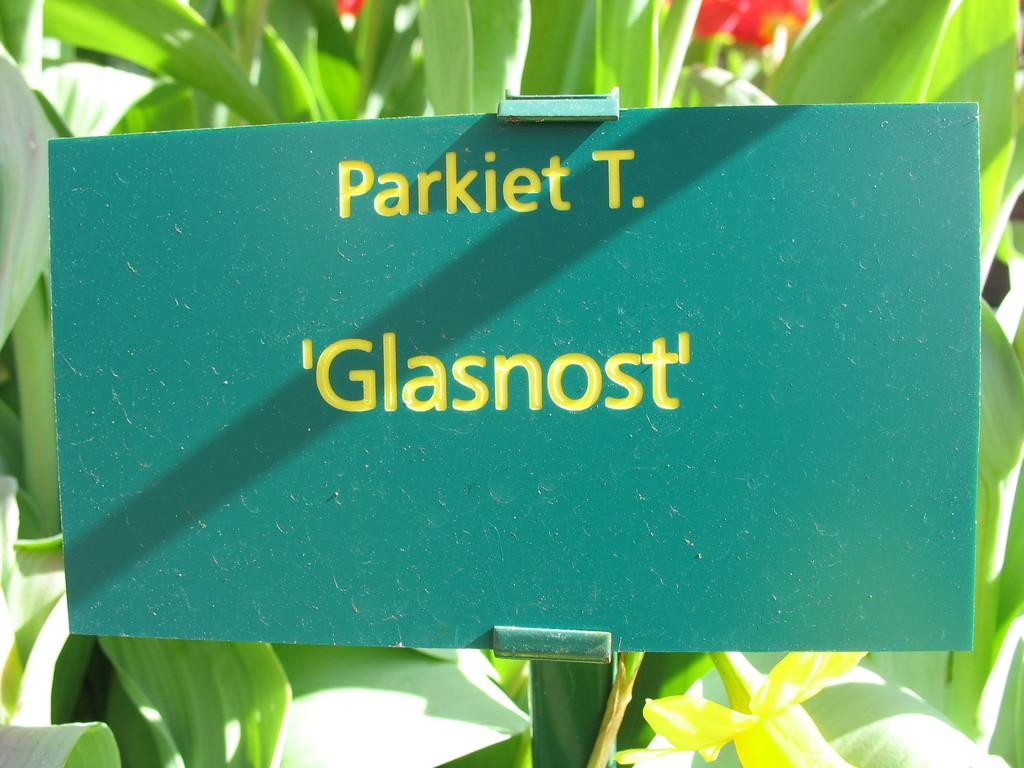What type of vegetation can be seen in the background of the image? There are plants in the background of the image. Can you identify any specific flowers among the plants? Yes, there appears to be a red flower among the plants. What is the primary color of the board in the image? The image is mainly highlighted with a green board. Is there any text or drawing on the green board? Yes, there is something written on the green board. What type of metal is used to create the bait for the fish in the image? There is no mention of fish or bait in the image, so it is not possible to determine the type of metal used. Can you describe the self-portrait of the person in the image? There is no person or self-portrait present in the image. 